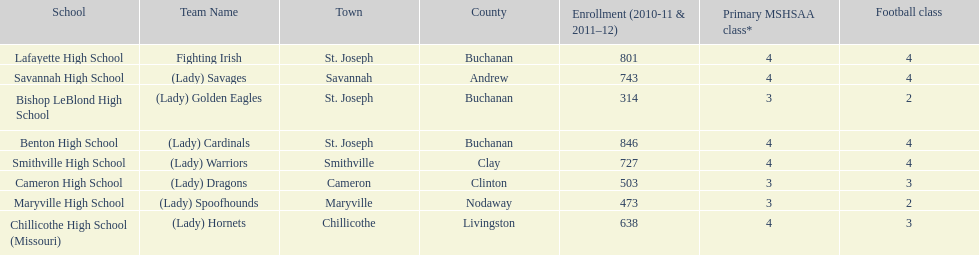How many teams are named after birds? 2. 